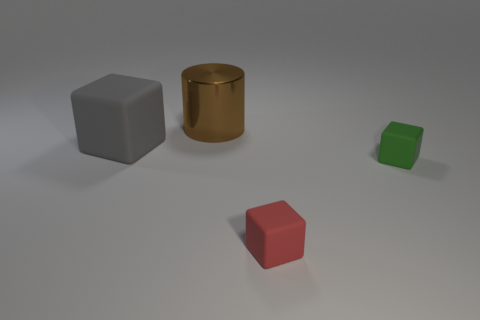There is a green cube; what number of small red rubber objects are behind it?
Your answer should be very brief. 0. What color is the other small rubber thing that is the same shape as the green rubber thing?
Ensure brevity in your answer.  Red. Is the tiny cube that is in front of the small green block made of the same material as the cube on the left side of the small red rubber cube?
Provide a short and direct response. Yes. The thing that is both behind the small green thing and in front of the big shiny object has what shape?
Offer a terse response. Cube. What number of tiny red matte cubes are there?
Your answer should be compact. 1. What size is the red object that is the same shape as the green object?
Keep it short and to the point. Small. There is a matte object that is left of the red rubber object; does it have the same shape as the large brown object?
Ensure brevity in your answer.  No. There is a big thing that is on the right side of the large gray cube; what is its color?
Your response must be concise. Brown. Is there anything else that is the same shape as the small green thing?
Your answer should be compact. Yes. Are there an equal number of shiny cylinders that are to the left of the gray thing and gray rubber cylinders?
Offer a very short reply. Yes. 